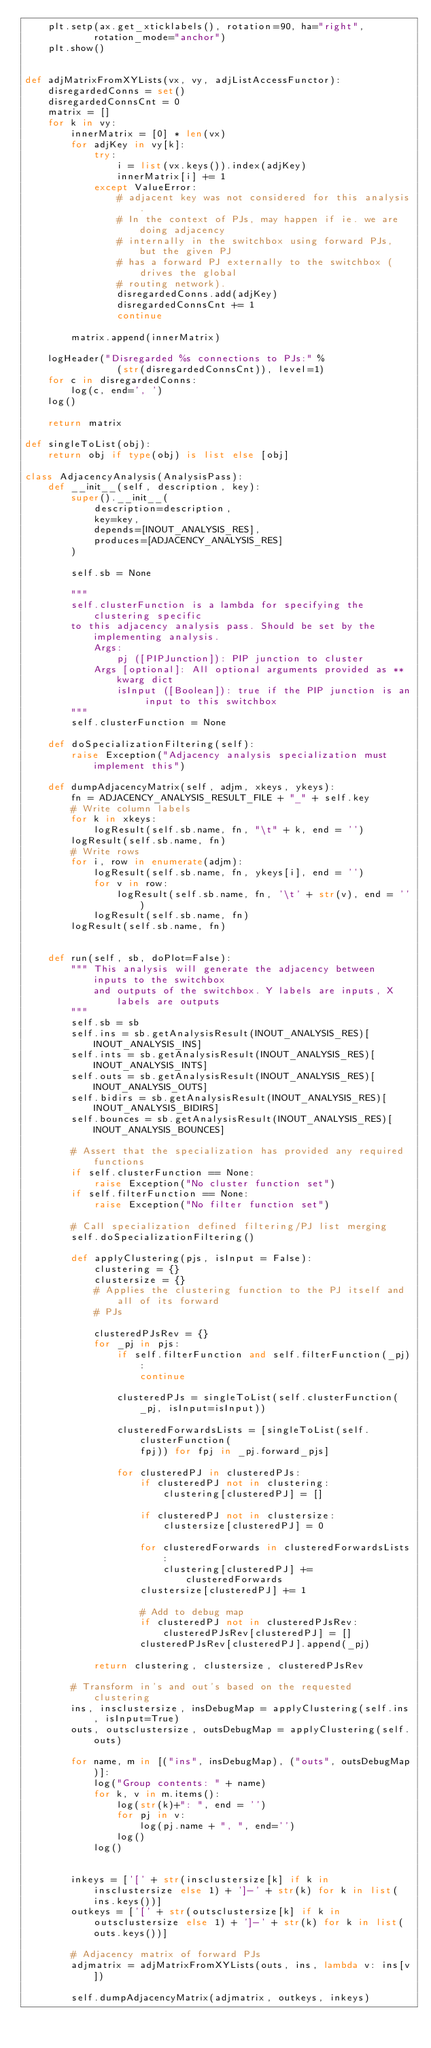<code> <loc_0><loc_0><loc_500><loc_500><_Python_>    plt.setp(ax.get_xticklabels(), rotation=90, ha="right",
            rotation_mode="anchor")
    plt.show()


def adjMatrixFromXYLists(vx, vy, adjListAccessFunctor):
    disregardedConns = set()
    disregardedConnsCnt = 0
    matrix = []
    for k in vy:
        innerMatrix = [0] * len(vx)
        for adjKey in vy[k]:
            try:
                i = list(vx.keys()).index(adjKey)
                innerMatrix[i] += 1
            except ValueError:
                # adjacent key was not considered for this analysis.
                # In the context of PJs, may happen if ie. we are doing adjacency
                # internally in the switchbox using forward PJs, but the given PJ
                # has a forward PJ externally to the switchbox (drives the global
                # routing network).
                disregardedConns.add(adjKey)
                disregardedConnsCnt += 1
                continue

        matrix.append(innerMatrix)

    logHeader("Disregarded %s connections to PJs:" %
                (str(disregardedConnsCnt)), level=1)
    for c in disregardedConns:
        log(c, end=', ')
    log()

    return matrix

def singleToList(obj):
    return obj if type(obj) is list else [obj]

class AdjacencyAnalysis(AnalysisPass):
    def __init__(self, description, key):
        super().__init__(
            description=description,
            key=key,
            depends=[INOUT_ANALYSIS_RES],
            produces=[ADJACENCY_ANALYSIS_RES]
        )

        self.sb = None

        """
        self.clusterFunction is a lambda for specifying the clustering specific
        to this adjacency analysis pass. Should be set by the implementing analysis.
            Args:
                pj ([PIPJunction]): PIP junction to cluster
            Args [optional]: All optional arguments provided as **kwarg dict
                isInput ([Boolean]): true if the PIP junction is an input to this switchbox
        """        
        self.clusterFunction = None

    def doSpecializationFiltering(self):
        raise Exception("Adjacency analysis specialization must implement this")

    def dumpAdjacencyMatrix(self, adjm, xkeys, ykeys):
        fn = ADJACENCY_ANALYSIS_RESULT_FILE + "_" + self.key
        # Write column labels
        for k in xkeys:
            logResult(self.sb.name, fn, "\t" + k, end = '')
        logResult(self.sb.name, fn)
        # Write rows
        for i, row in enumerate(adjm):
            logResult(self.sb.name, fn, ykeys[i], end = '')
            for v in row:
                logResult(self.sb.name, fn, '\t' + str(v), end = '')
            logResult(self.sb.name, fn)
        logResult(self.sb.name, fn)


    def run(self, sb, doPlot=False):
        """ This analysis will generate the adjacency between inputs to the switchbox
            and outputs of the switchbox. Y labels are inputs, X labels are outputs
        """
        self.sb = sb
        self.ins = sb.getAnalysisResult(INOUT_ANALYSIS_RES)[INOUT_ANALYSIS_INS]
        self.ints = sb.getAnalysisResult(INOUT_ANALYSIS_RES)[INOUT_ANALYSIS_INTS]
        self.outs = sb.getAnalysisResult(INOUT_ANALYSIS_RES)[INOUT_ANALYSIS_OUTS]
        self.bidirs = sb.getAnalysisResult(INOUT_ANALYSIS_RES)[INOUT_ANALYSIS_BIDIRS]
        self.bounces = sb.getAnalysisResult(INOUT_ANALYSIS_RES)[INOUT_ANALYSIS_BOUNCES]

        # Assert that the specialization has provided any required functions
        if self.clusterFunction == None:
            raise Exception("No cluster function set")
        if self.filterFunction == None:
            raise Exception("No filter function set")

        # Call specialization defined filtering/PJ list merging
        self.doSpecializationFiltering()

        def applyClustering(pjs, isInput = False):
            clustering = {}
            clustersize = {}
            # Applies the clustering function to the PJ itself and all of its forward
            # PJs

            clusteredPJsRev = {}
            for _pj in pjs:
                if self.filterFunction and self.filterFunction(_pj):
                    continue

                clusteredPJs = singleToList(self.clusterFunction(_pj, isInput=isInput))
                
                clusteredForwardsLists = [singleToList(self.clusterFunction(
                    fpj)) for fpj in _pj.forward_pjs]

                for clusteredPJ in clusteredPJs:
                    if clusteredPJ not in clustering:
                        clustering[clusteredPJ] = []

                    if clusteredPJ not in clustersize:
                        clustersize[clusteredPJ] = 0

                    for clusteredForwards in clusteredForwardsLists:
                        clustering[clusteredPJ] += clusteredForwards
                    clustersize[clusteredPJ] += 1

                    # Add to debug map
                    if clusteredPJ not in clusteredPJsRev:
                        clusteredPJsRev[clusteredPJ] = []
                    clusteredPJsRev[clusteredPJ].append(_pj)

            return clustering, clustersize, clusteredPJsRev

        # Transform in's and out's based on the requested clustering
        ins, insclustersize, insDebugMap = applyClustering(self.ins, isInput=True)
        outs, outsclustersize, outsDebugMap = applyClustering(self.outs)

        for name, m in [("ins", insDebugMap), ("outs", outsDebugMap)]:
            log("Group contents: " + name)
            for k, v in m.items():
                log(str(k)+": ", end = '')
                for pj in v:
                    log(pj.name + ", ", end='')
                log()
            log()


        inkeys = ['[' + str(insclustersize[k] if k in insclustersize else 1) + ']-' + str(k) for k in list(ins.keys())]
        outkeys = ['[' + str(outsclustersize[k] if k in outsclustersize else 1) + ']-' + str(k) for k in list(outs.keys())]

        # Adjacency matrix of forward PJs
        adjmatrix = adjMatrixFromXYLists(outs, ins, lambda v: ins[v])

        self.dumpAdjacencyMatrix(adjmatrix, outkeys, inkeys)
</code> 